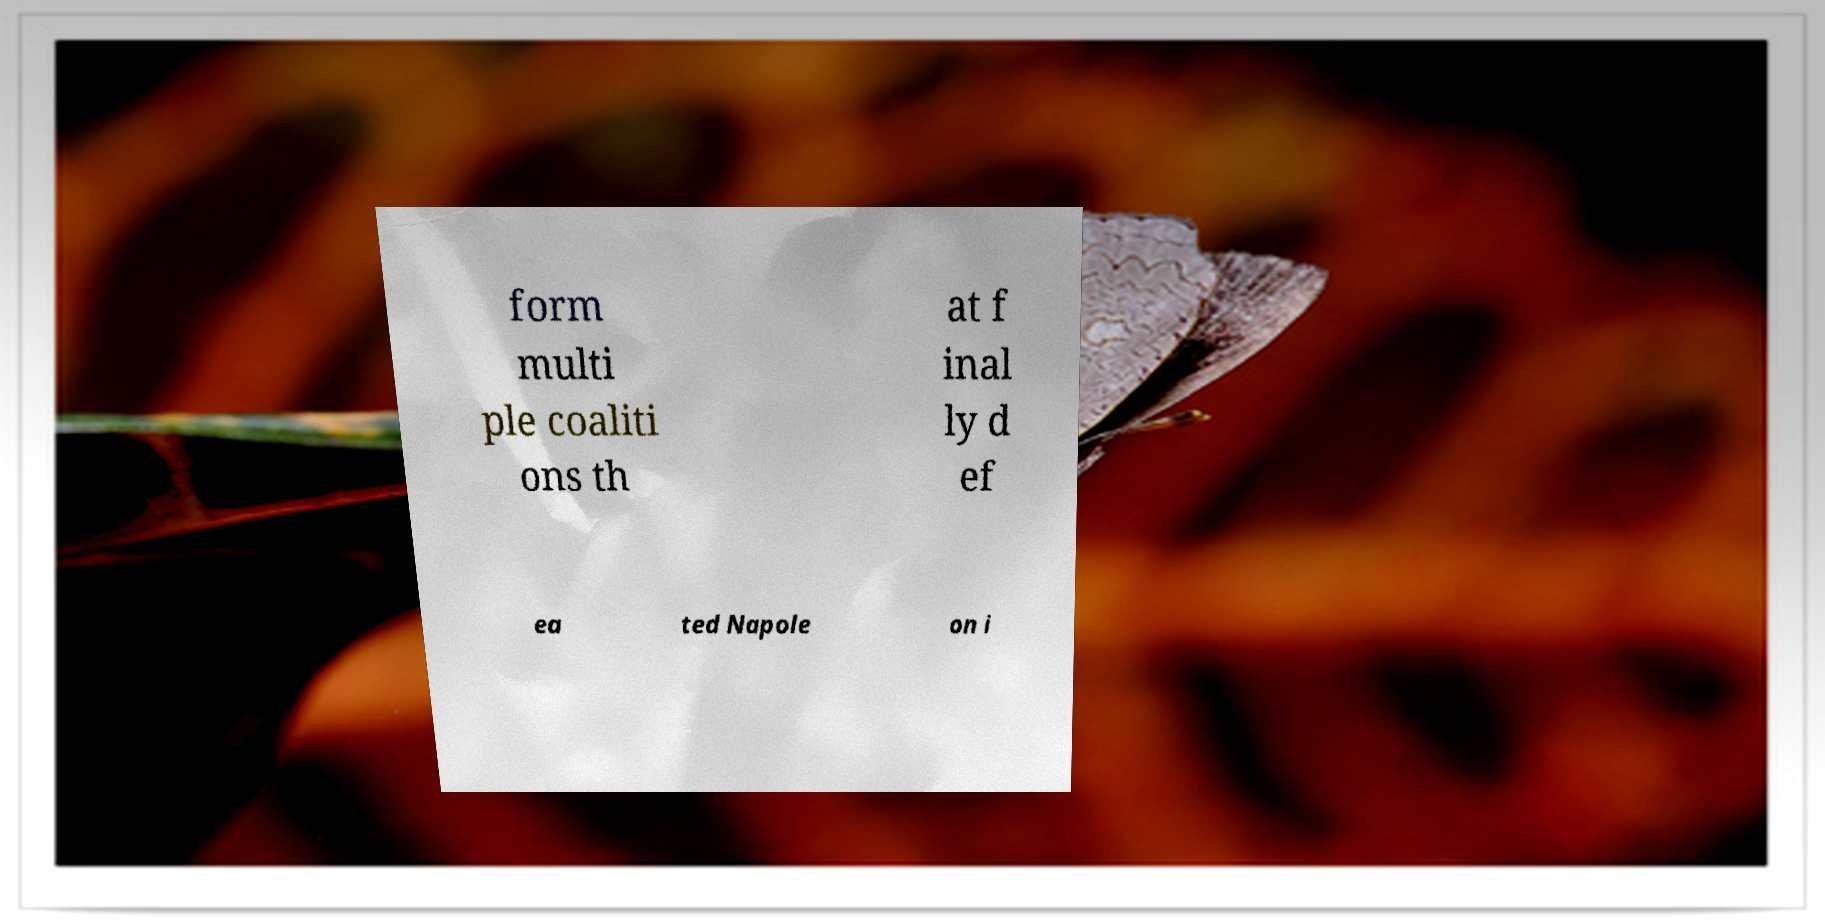Can you read and provide the text displayed in the image?This photo seems to have some interesting text. Can you extract and type it out for me? form multi ple coaliti ons th at f inal ly d ef ea ted Napole on i 